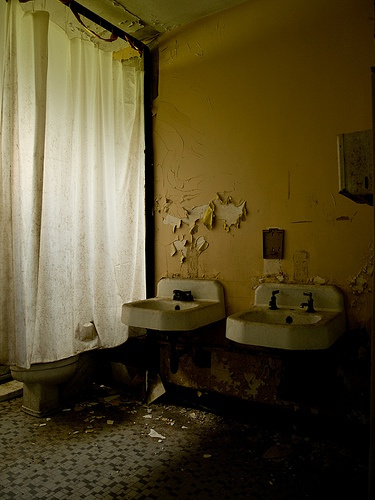Describe the objects in this image and their specific colors. I can see sink in olive, black, and darkgreen tones, sink in olive and black tones, and toilet in olive, black, and darkgreen tones in this image. 